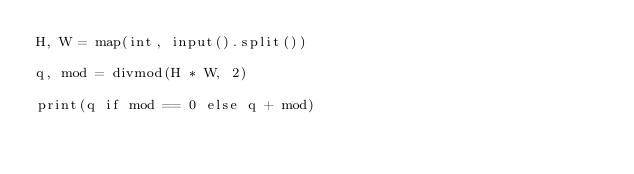Convert code to text. <code><loc_0><loc_0><loc_500><loc_500><_Python_>H, W = map(int, input().split())

q, mod = divmod(H * W, 2)

print(q if mod == 0 else q + mod)
</code> 